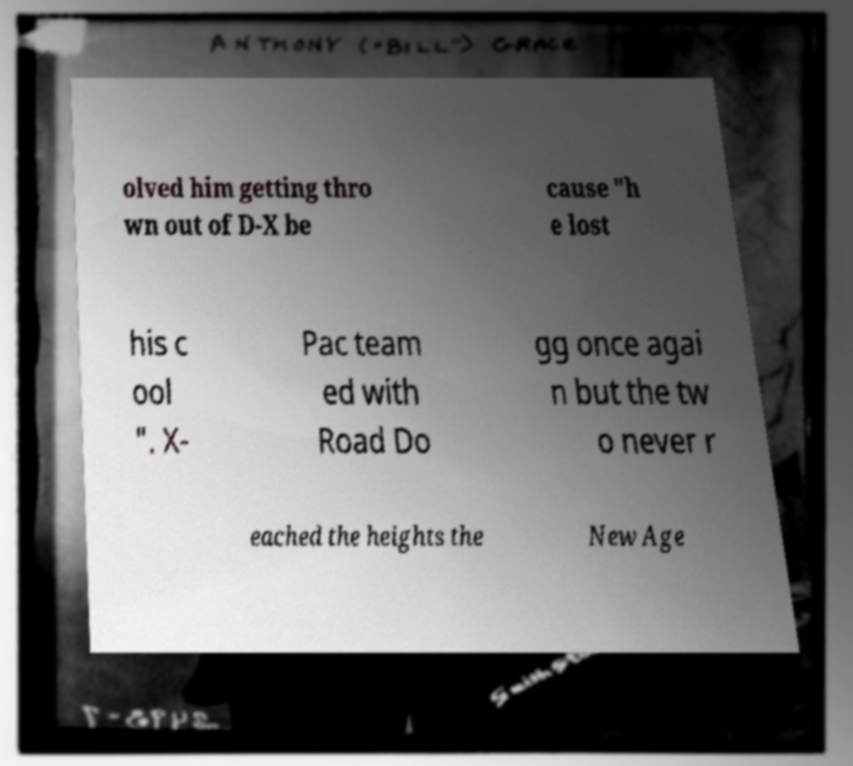Could you assist in decoding the text presented in this image and type it out clearly? olved him getting thro wn out of D-X be cause "h e lost his c ool ". X- Pac team ed with Road Do gg once agai n but the tw o never r eached the heights the New Age 